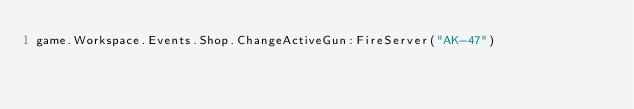<code> <loc_0><loc_0><loc_500><loc_500><_Lua_>game.Workspace.Events.Shop.ChangeActiveGun:FireServer("AK-47")</code> 